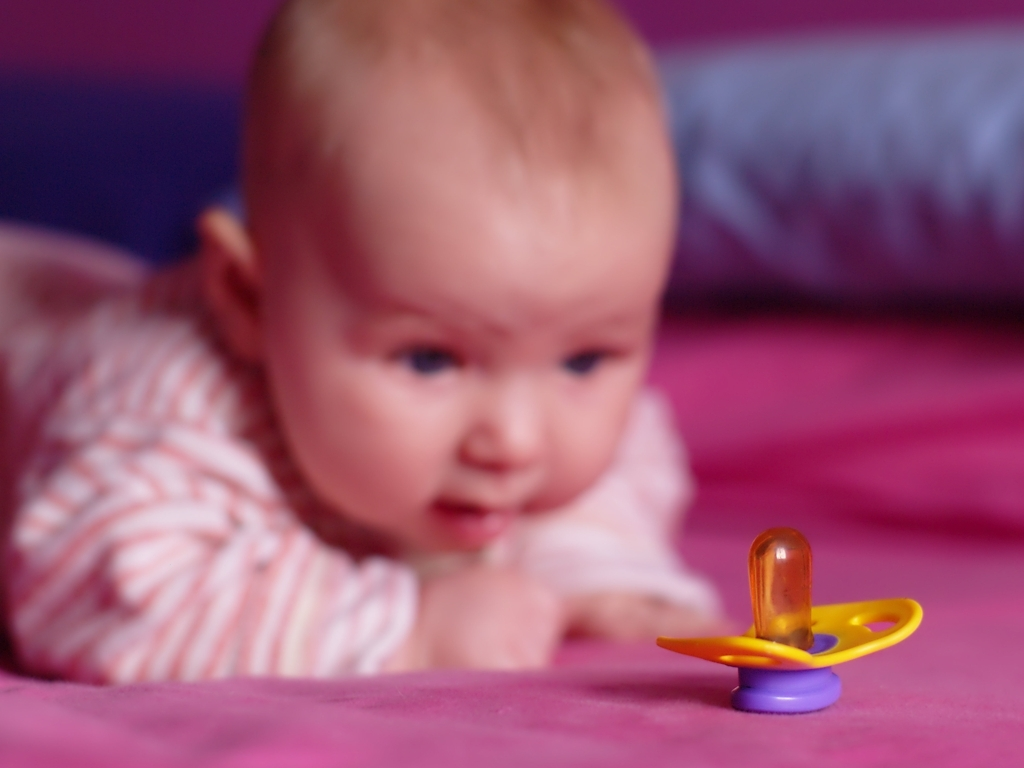What is the overall quality of this photo? A. Poor B. High C. Excellent D. Mediocre to low Answer with the option's letter from the given choices directly. The quality of the photo is not high due to several factors. The most noticeable issue is the focus; the infant is not in sharp focus, which is generally the subject of interest. This detracts from the clarity of the image. The depth of field is shallow, and while this effect can be artistically appealing, it does not compensate for the main subject being out of focus. The lighting appears natural, which is typically pleasing, but it's not sufficient to illuminate the subject's face clearly. Additionally, the composition could be improved to enhance its impact. Therefore, the overall quality of the photo leans towards option D. Mediocre to low. 